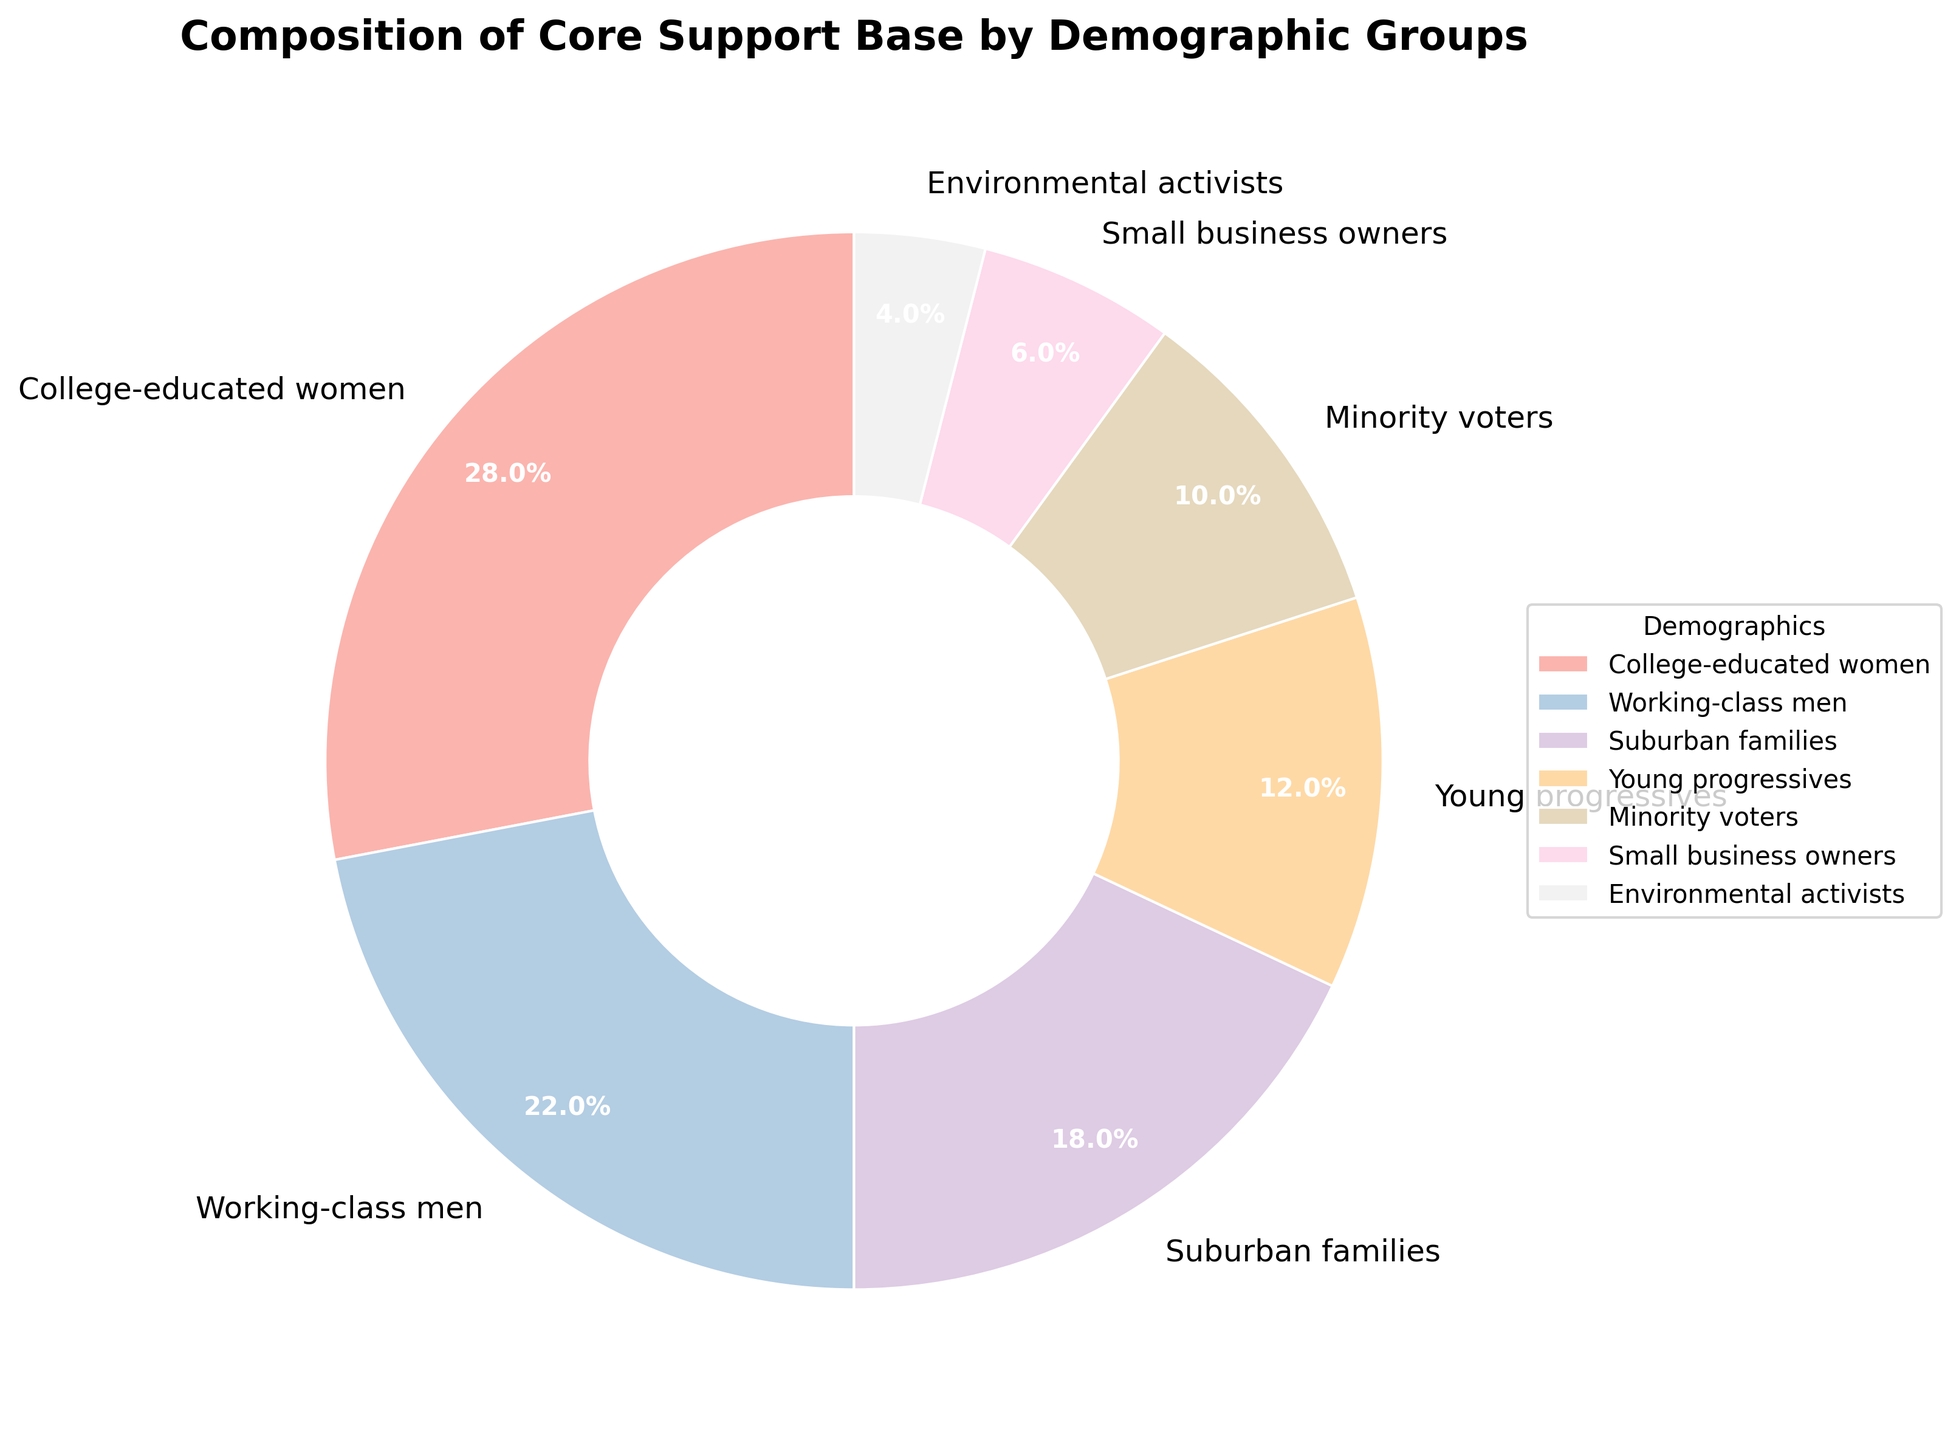What's the total percentage of 'College-educated women' and 'Working-class men'? Add the percentages of 'College-educated women' (28%) and 'Working-class men' (22%). 28% + 22% = 50%.
Answer: 50% Which demographic group has the lowest representation? Identify the demographic with the smallest percentage. 'Environmental activists' is the smallest with 4%.
Answer: Environmental activists How much larger is the percentage of 'College-educated women' compared to 'Environmental activists'? Subtract the percentage of 'Environmental activists' (4%) from 'College-educated women' (28%). 28% - 4% = 24%.
Answer: 24% What is the combined percentage of 'Suburban families' and 'Young progressives'? Add the percentages of 'Suburban families' (18%) and 'Young progressives' (12%). 18% + 12% = 30%.
Answer: 30% Which two demographic groups make up the smallest combined percentage? Identify the two smallest groups: 'Environmental activists' (4%) and 'Small business owners' (6%). Add their percentages. 4% + 6% = 10%.
Answer: Environmental activists and Small business owners What is the percentage difference between 'Minority voters' and 'Small business owners'? Subtract the percentage of 'Small business owners' (6%) from 'Minority voters' (10%). 10% - 6% = 4%.
Answer: 4% Which group represents 18% of the support base? Identify the group with an 18% slice in the pie chart. 'Suburban families' represents 18%.
Answer: Suburban families Between 'Young progressives' and 'Minority voters', which group has a higher percentage and by how much? Compare the percentages of 'Young progressives' (12%) and 'Minority voters' (10%). Subtract the smaller percentage from the larger. 12% - 10% = 2%.
Answer: Young progressives, by 2% What is the average percentage of 'Working-class men', 'Young progressives', and 'Minority voters'? Add the percentages of the three groups: 22%, 12%, and 10%. Then divide by 3: (22 + 12 + 10) / 3 = 14.67%.
Answer: 14.67% If you combine 'Small business owners' and 'Environmental activists', how close is their total percentage to the percentage of 'Young progressives'? Add the percentages of 'Small business owners' (6%) and 'Environmental activists' (4%): 6% + 4% = 10%. Compare this with 'Young progressives' (12%). Difference is 12% - 10% = 2%.
Answer: 2% 